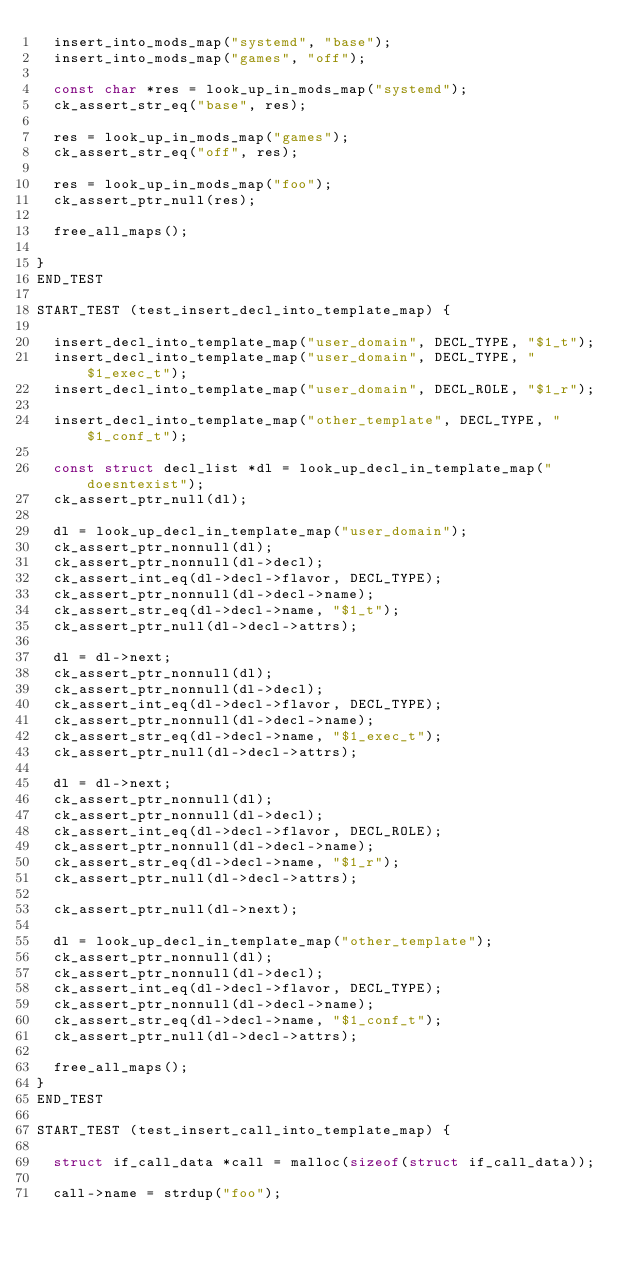<code> <loc_0><loc_0><loc_500><loc_500><_C_>	insert_into_mods_map("systemd", "base");
	insert_into_mods_map("games", "off");

	const char *res = look_up_in_mods_map("systemd");
	ck_assert_str_eq("base", res);

	res = look_up_in_mods_map("games");
	ck_assert_str_eq("off", res);

	res = look_up_in_mods_map("foo");
	ck_assert_ptr_null(res);

	free_all_maps();

}
END_TEST

START_TEST (test_insert_decl_into_template_map) {

	insert_decl_into_template_map("user_domain", DECL_TYPE, "$1_t");
	insert_decl_into_template_map("user_domain", DECL_TYPE, "$1_exec_t");
	insert_decl_into_template_map("user_domain", DECL_ROLE, "$1_r");

	insert_decl_into_template_map("other_template", DECL_TYPE, "$1_conf_t");

	const struct decl_list *dl = look_up_decl_in_template_map("doesntexist");
	ck_assert_ptr_null(dl);

	dl = look_up_decl_in_template_map("user_domain");
	ck_assert_ptr_nonnull(dl);
	ck_assert_ptr_nonnull(dl->decl);
	ck_assert_int_eq(dl->decl->flavor, DECL_TYPE);
	ck_assert_ptr_nonnull(dl->decl->name);
	ck_assert_str_eq(dl->decl->name, "$1_t");
	ck_assert_ptr_null(dl->decl->attrs);

	dl = dl->next;
	ck_assert_ptr_nonnull(dl);
	ck_assert_ptr_nonnull(dl->decl);
	ck_assert_int_eq(dl->decl->flavor, DECL_TYPE);
	ck_assert_ptr_nonnull(dl->decl->name);
	ck_assert_str_eq(dl->decl->name, "$1_exec_t");
	ck_assert_ptr_null(dl->decl->attrs);

	dl = dl->next;
	ck_assert_ptr_nonnull(dl);
	ck_assert_ptr_nonnull(dl->decl);
	ck_assert_int_eq(dl->decl->flavor, DECL_ROLE);
	ck_assert_ptr_nonnull(dl->decl->name);
	ck_assert_str_eq(dl->decl->name, "$1_r");
	ck_assert_ptr_null(dl->decl->attrs);

	ck_assert_ptr_null(dl->next);

	dl = look_up_decl_in_template_map("other_template");
	ck_assert_ptr_nonnull(dl);
	ck_assert_ptr_nonnull(dl->decl);
	ck_assert_int_eq(dl->decl->flavor, DECL_TYPE);
	ck_assert_ptr_nonnull(dl->decl->name);
	ck_assert_str_eq(dl->decl->name, "$1_conf_t");
	ck_assert_ptr_null(dl->decl->attrs);

	free_all_maps();
}
END_TEST

START_TEST (test_insert_call_into_template_map) {

	struct if_call_data *call = malloc(sizeof(struct if_call_data));

	call->name = strdup("foo");</code> 